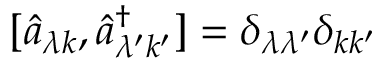Convert formula to latex. <formula><loc_0><loc_0><loc_500><loc_500>[ \hat { a } _ { \lambda k } , \hat { a } _ { \lambda ^ { \prime } k ^ { \prime } } ^ { \dagger } ] = \delta _ { \lambda \lambda ^ { \prime } } \delta _ { k k ^ { \prime } }</formula> 